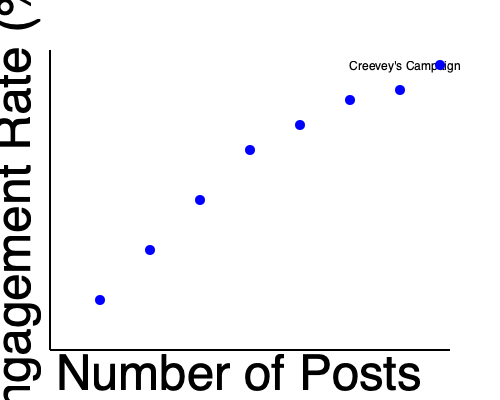Based on the scatter plot showing the relationship between the number of social media posts and engagement rate for Anthony Creevey's political campaign, what trend can be observed, and how might this inform future campaign strategies? To analyze the trend in the scatter plot and its implications for future campaign strategies, let's follow these steps:

1. Observe the overall pattern:
   The scatter plot shows a clear negative correlation between the number of posts and the engagement rate.

2. Interpret the relationship:
   As the number of posts increases, the engagement rate tends to decrease.

3. Quantify the trend:
   The engagement rate starts high (around 25-30%) with fewer posts and drops to about 5-10% with a higher number of posts.

4. Consider the implications:
   a. Quality over quantity: The data suggests that posting less frequently might lead to higher engagement rates.
   b. Content saturation: Too many posts may lead to audience fatigue or decreased interest per post.
   c. Optimal posting frequency: There might be a "sweet spot" where engagement is maximized without overwhelming the audience.

5. Strategize for future campaigns:
   a. Focus on creating high-quality, engaging content rather than increasing post frequency.
   b. Experiment with different posting schedules to find the optimal frequency for engagement.
   c. Monitor engagement rates closely and adjust the posting strategy accordingly.
   d. Consider the timing and relevance of posts to maximize impact.

6. Additional considerations:
   a. The type and content of posts may also influence engagement rates.
   b. External factors (e.g., campaign events, news cycles) could affect engagement.
   c. The specific platform(s) used may have different optimal posting frequencies.

By understanding this trend, Creevey's campaign can refine its social media strategy to maximize engagement and potentially improve the overall effectiveness of the campaign's online presence.
Answer: Negative correlation between post frequency and engagement rate; suggest focusing on quality over quantity in future campaign strategies. 